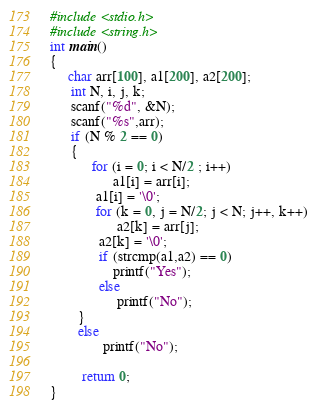Convert code to text. <code><loc_0><loc_0><loc_500><loc_500><_C_>#include <stdio.h>
#include <string.h>
int main()
{
     char arr[100], a1[200], a2[200];
      int N, i, j, k;
      scanf("%d", &N);
      scanf("%s",arr);
      if (N % 2 == 0)
      {
            for (i = 0; i < N/2 ; i++)
                  a1[i] = arr[i];
             a1[i] = '\0';
             for (k = 0, j = N/2; j < N; j++, k++)
                   a2[k] = arr[j];
              a2[k] = '\0';
              if (strcmp(a1,a2) == 0)
                  printf("Yes");
              else
                   printf("No");
        }
        else
               printf("No");

         return 0;
}</code> 